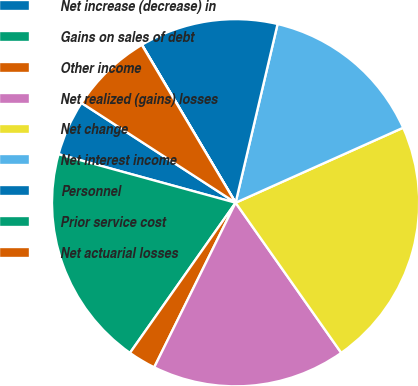Convert chart to OTSL. <chart><loc_0><loc_0><loc_500><loc_500><pie_chart><fcel>Net increase (decrease) in<fcel>Gains on sales of debt<fcel>Other income<fcel>Net realized (gains) losses<fcel>Net change<fcel>Net interest income<fcel>Personnel<fcel>Prior service cost<fcel>Net actuarial losses<nl><fcel>4.89%<fcel>19.5%<fcel>2.45%<fcel>17.07%<fcel>21.94%<fcel>14.63%<fcel>12.19%<fcel>0.02%<fcel>7.32%<nl></chart> 